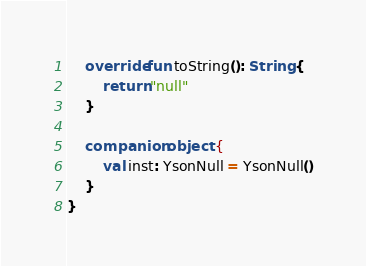Convert code to text. <code><loc_0><loc_0><loc_500><loc_500><_Kotlin_>

	override fun toString(): String {
		return "null"
	}

	companion object {
		val inst: YsonNull = YsonNull()
	}
}</code> 